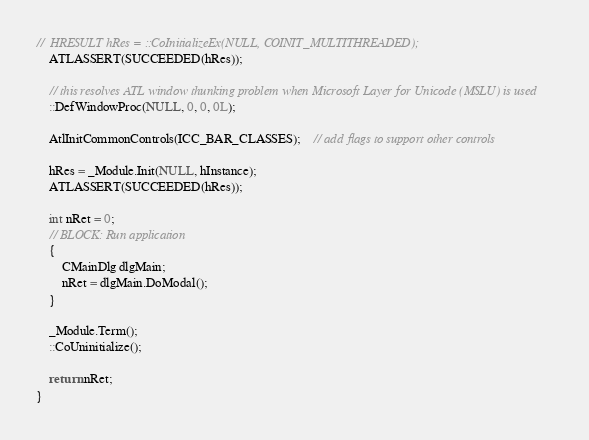<code> <loc_0><loc_0><loc_500><loc_500><_C++_>//	HRESULT hRes = ::CoInitializeEx(NULL, COINIT_MULTITHREADED);
	ATLASSERT(SUCCEEDED(hRes));

	// this resolves ATL window thunking problem when Microsoft Layer for Unicode (MSLU) is used
	::DefWindowProc(NULL, 0, 0, 0L);

	AtlInitCommonControls(ICC_BAR_CLASSES);	// add flags to support other controls

	hRes = _Module.Init(NULL, hInstance);
	ATLASSERT(SUCCEEDED(hRes));

	int nRet = 0;
	// BLOCK: Run application
	{
		CMainDlg dlgMain;
		nRet = dlgMain.DoModal();
	}

	_Module.Term();
	::CoUninitialize();

	return nRet;
}
</code> 